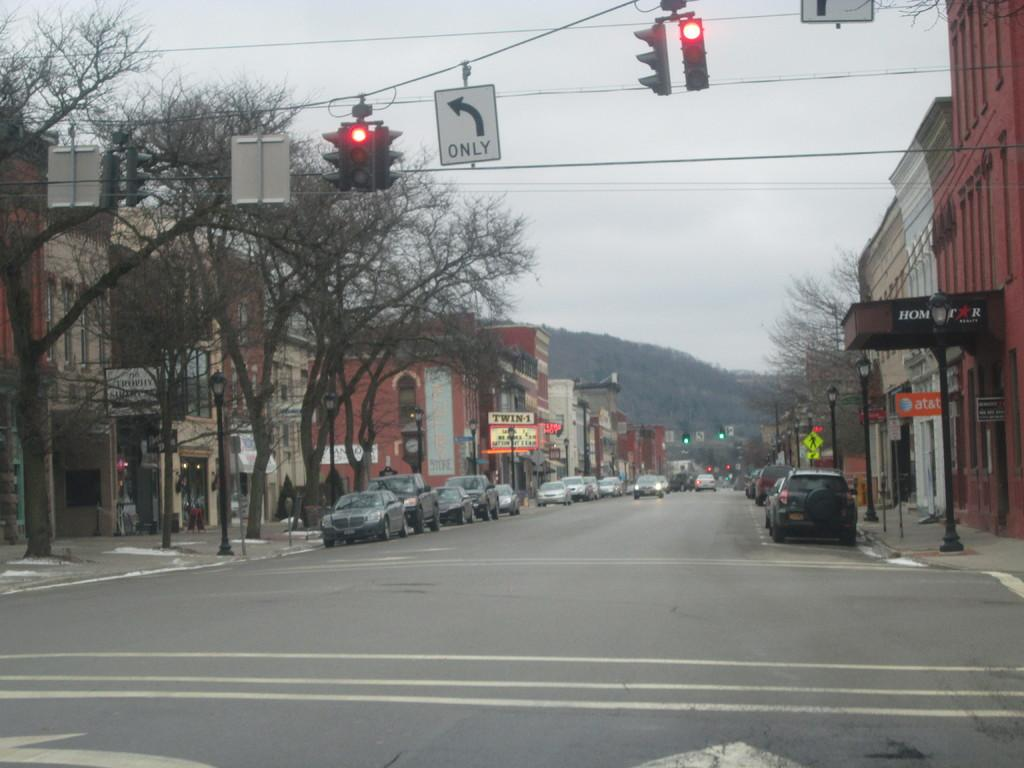<image>
Give a short and clear explanation of the subsequent image. A traffic light is hanging over an intersection next to a sign that says Only. 